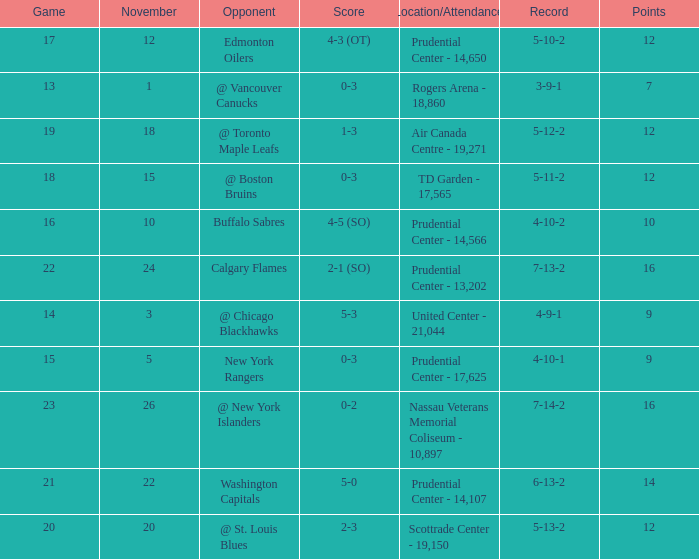Who was the opponent where the game is 14? @ Chicago Blackhawks. 